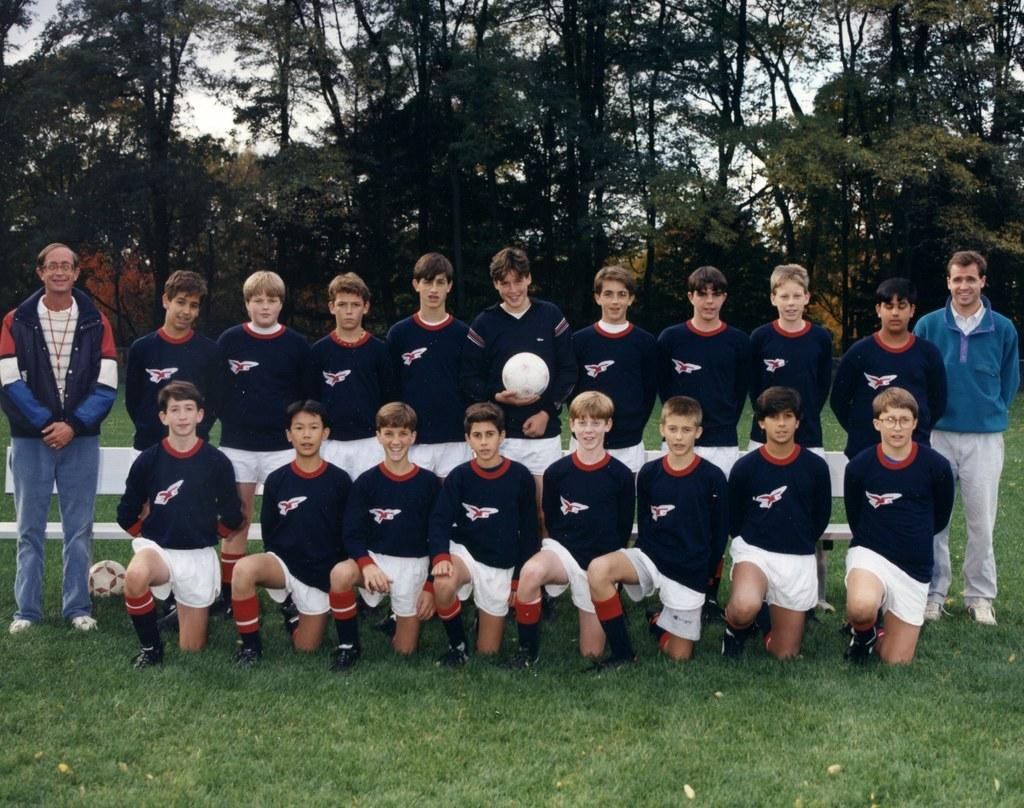What is the general arrangement of people in the image? There is a group of people standing and a group of people kneeling in the image. Can you describe the specific individuals in the image? Two men are standing in the image. What can be seen in the background of the image? There are trees visible in the background of the image. What type of war is being depicted in the image? There is no depiction of war in the image; it features a group of people standing and kneeling, as well as two men standing. How are the people being transported in the image? The people in the image are not being transported; they are standing or kneeling in place. 